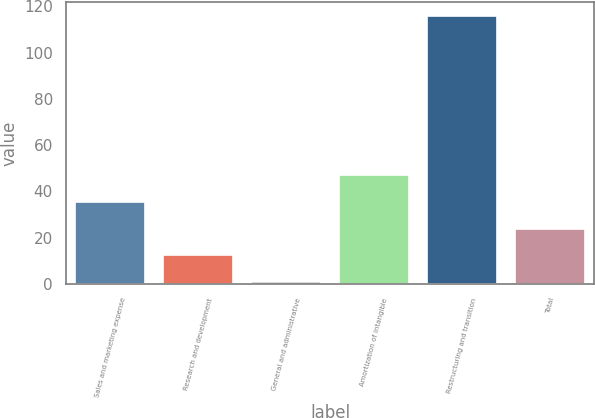Convert chart. <chart><loc_0><loc_0><loc_500><loc_500><bar_chart><fcel>Sales and marketing expense<fcel>Research and development<fcel>General and administrative<fcel>Amortization of intangible<fcel>Restructuring and transition<fcel>Total<nl><fcel>35.5<fcel>12.5<fcel>1<fcel>47<fcel>116<fcel>24<nl></chart> 